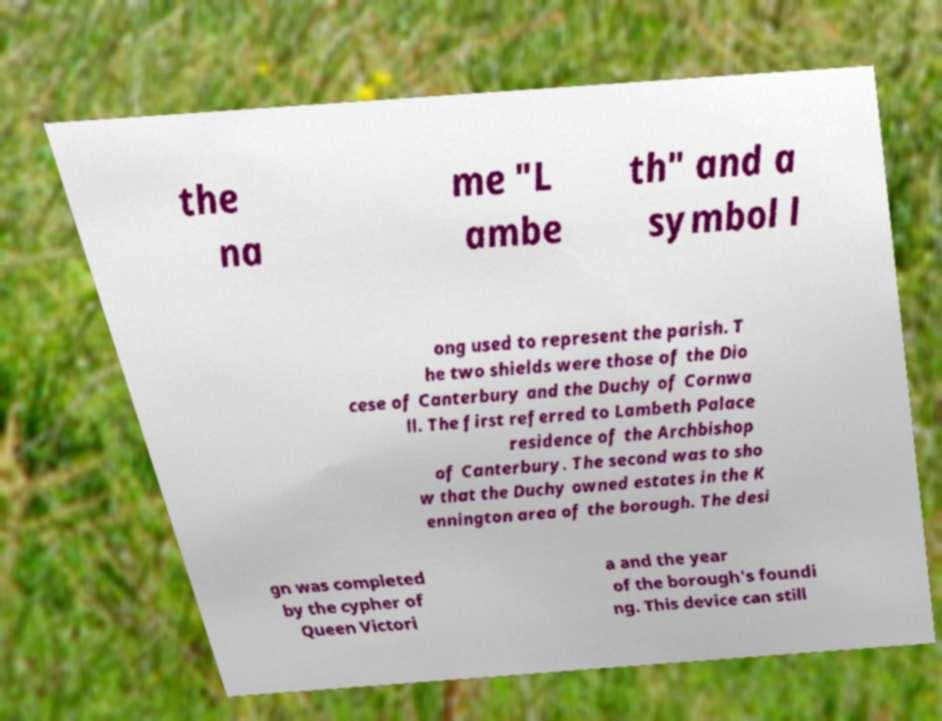I need the written content from this picture converted into text. Can you do that? the na me "L ambe th" and a symbol l ong used to represent the parish. T he two shields were those of the Dio cese of Canterbury and the Duchy of Cornwa ll. The first referred to Lambeth Palace residence of the Archbishop of Canterbury. The second was to sho w that the Duchy owned estates in the K ennington area of the borough. The desi gn was completed by the cypher of Queen Victori a and the year of the borough's foundi ng. This device can still 